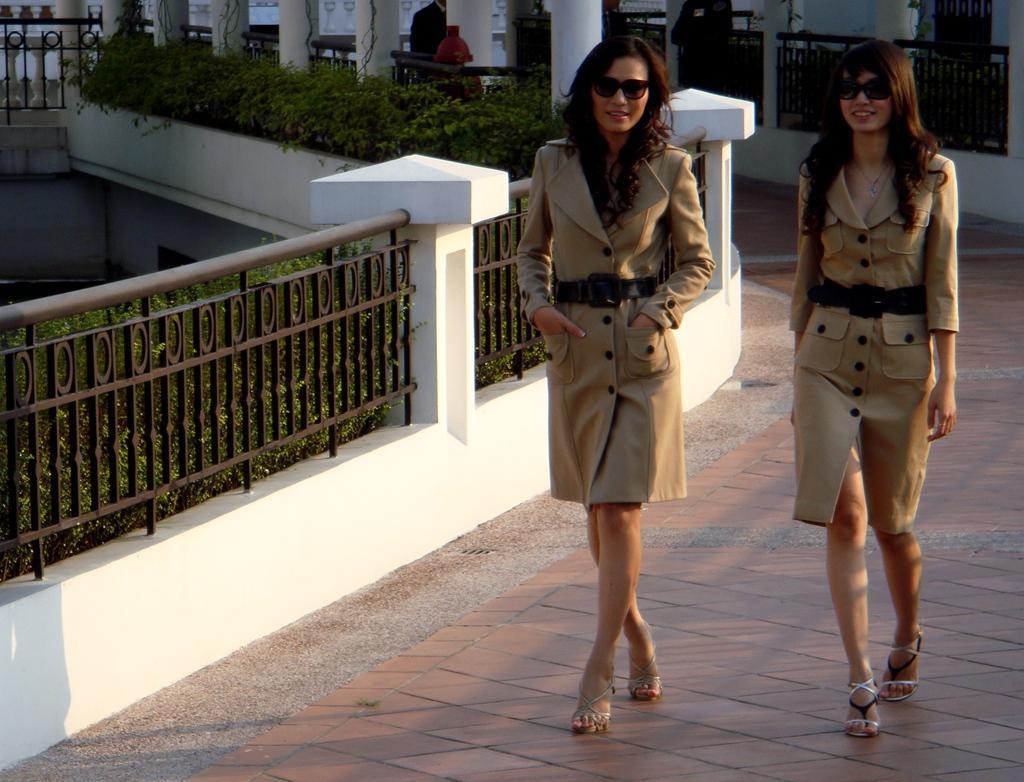Could you give a brief overview of what you see in this image? In this image we can see two ladies walking. On the left there is a fence and we can see shrubs. In the background there are pillars. 